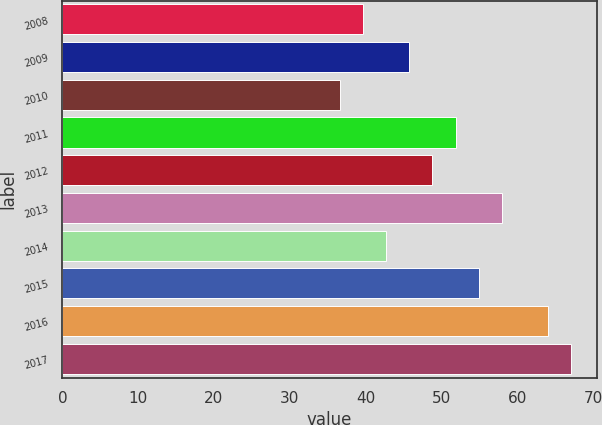Convert chart. <chart><loc_0><loc_0><loc_500><loc_500><bar_chart><fcel>2008<fcel>2009<fcel>2010<fcel>2011<fcel>2012<fcel>2013<fcel>2014<fcel>2015<fcel>2016<fcel>2017<nl><fcel>39.62<fcel>45.74<fcel>36.56<fcel>51.86<fcel>48.8<fcel>57.98<fcel>42.68<fcel>54.92<fcel>64.1<fcel>67.16<nl></chart> 